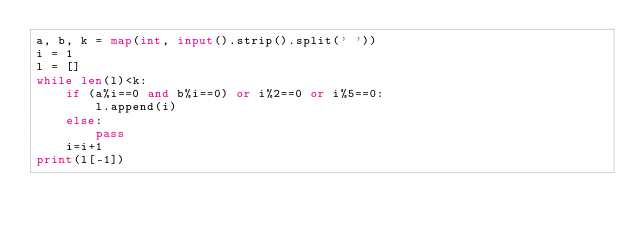<code> <loc_0><loc_0><loc_500><loc_500><_Python_>a, b, k = map(int, input().strip().split(' '))
i = 1
l = []
while len(l)<k:
    if (a%i==0 and b%i==0) or i%2==0 or i%5==0:
        l.append(i)
    else:
        pass
    i=i+1
print(l[-1])</code> 